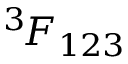Convert formula to latex. <formula><loc_0><loc_0><loc_500><loc_500>^ { 3 \, } F _ { 1 2 3 }</formula> 